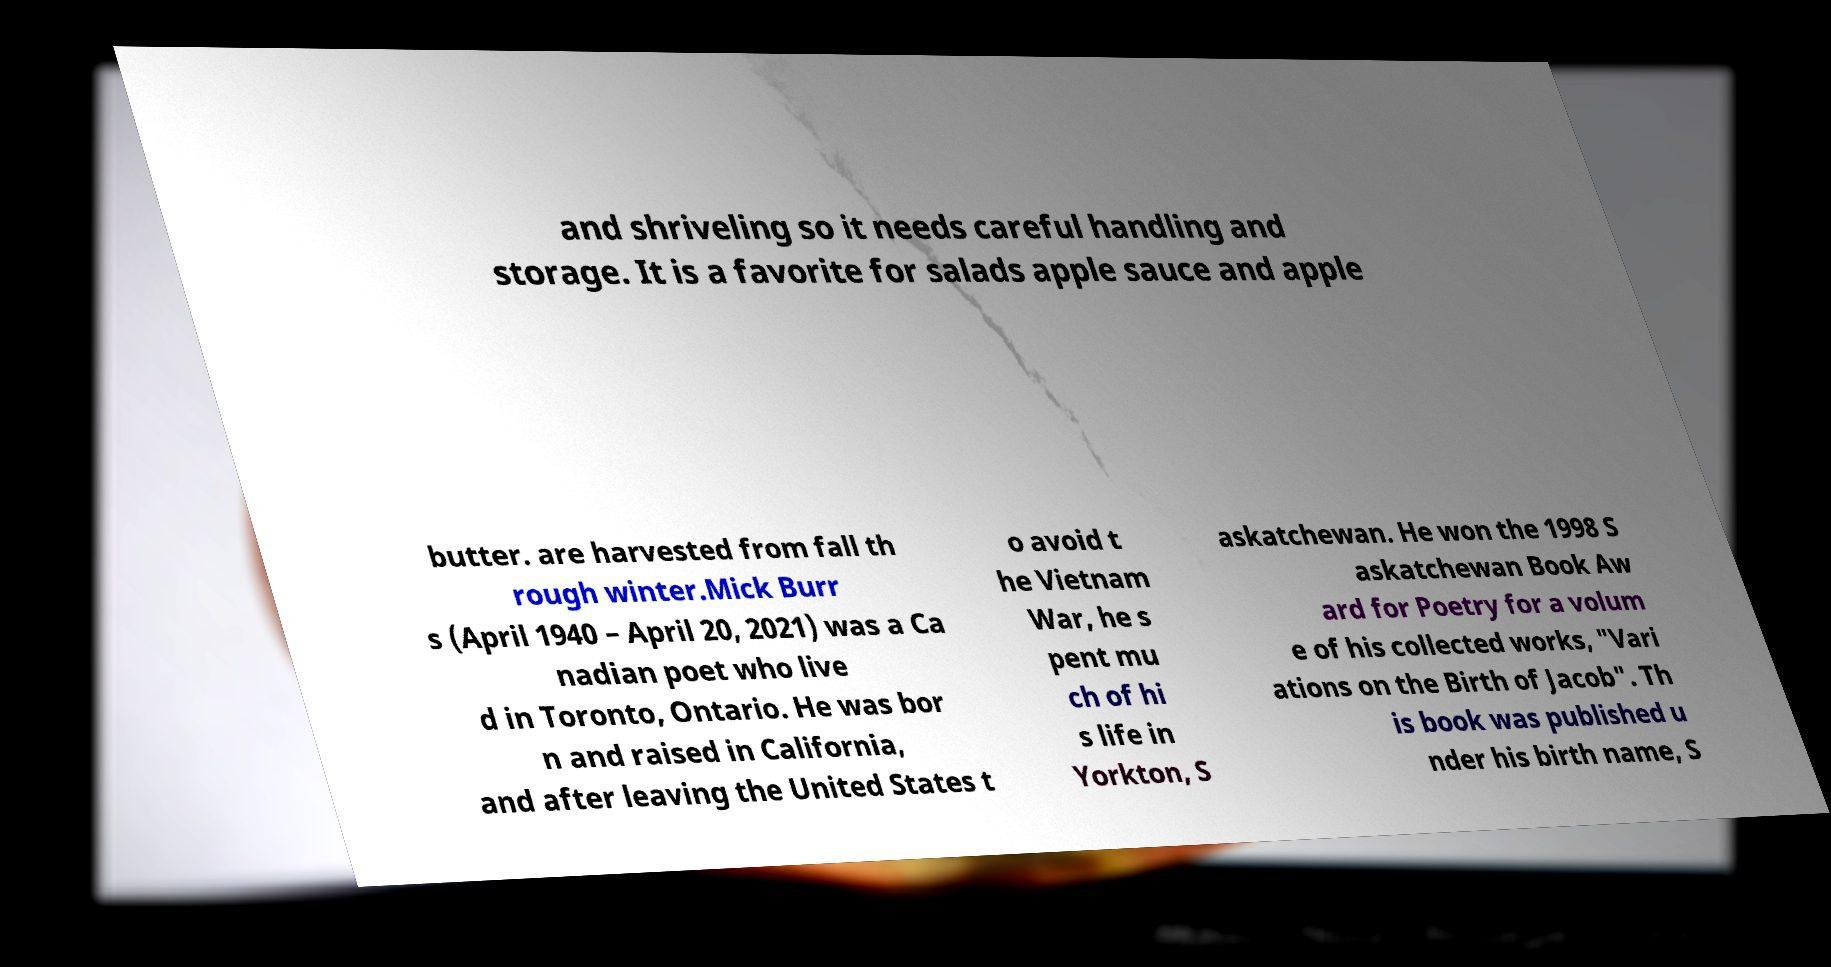For documentation purposes, I need the text within this image transcribed. Could you provide that? and shriveling so it needs careful handling and storage. It is a favorite for salads apple sauce and apple butter. are harvested from fall th rough winter.Mick Burr s (April 1940 – April 20, 2021) was a Ca nadian poet who live d in Toronto, Ontario. He was bor n and raised in California, and after leaving the United States t o avoid t he Vietnam War, he s pent mu ch of hi s life in Yorkton, S askatchewan. He won the 1998 S askatchewan Book Aw ard for Poetry for a volum e of his collected works, "Vari ations on the Birth of Jacob". Th is book was published u nder his birth name, S 